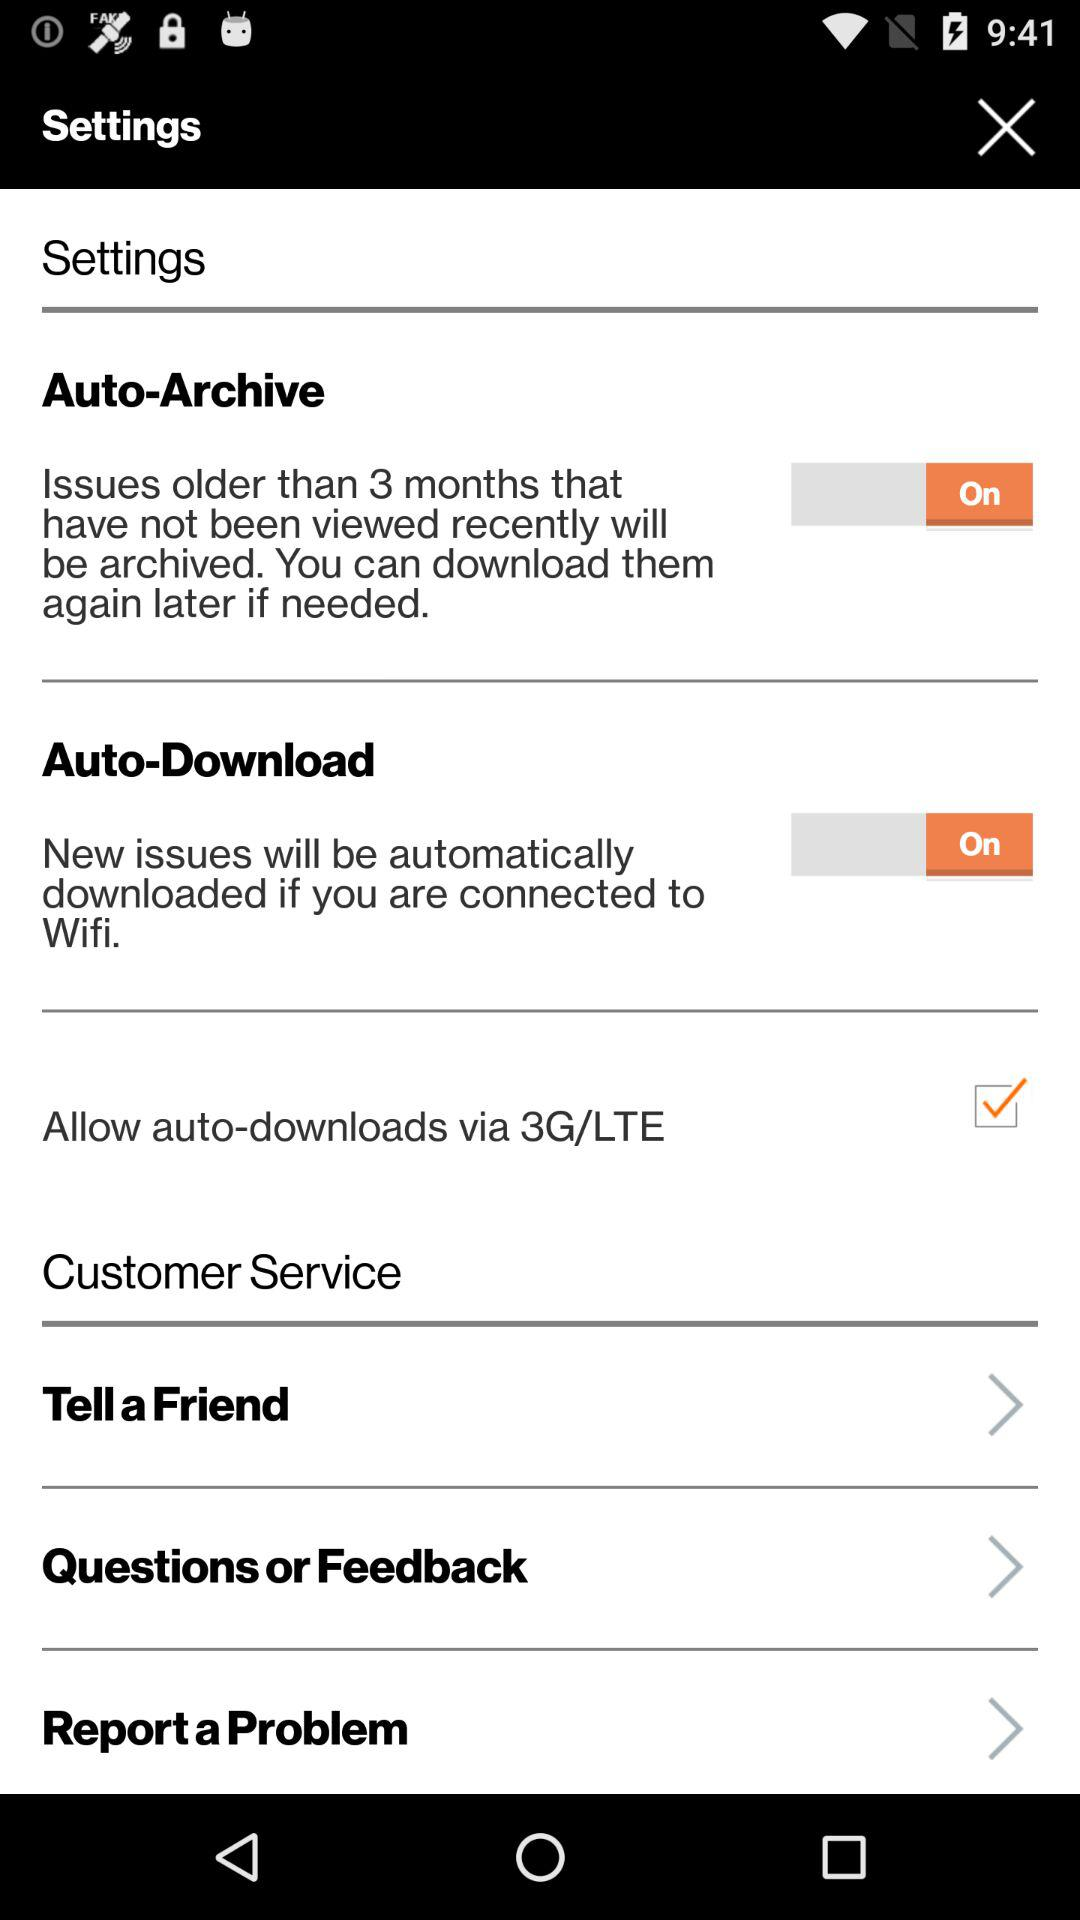How many items have a switch?
Answer the question using a single word or phrase. 2 